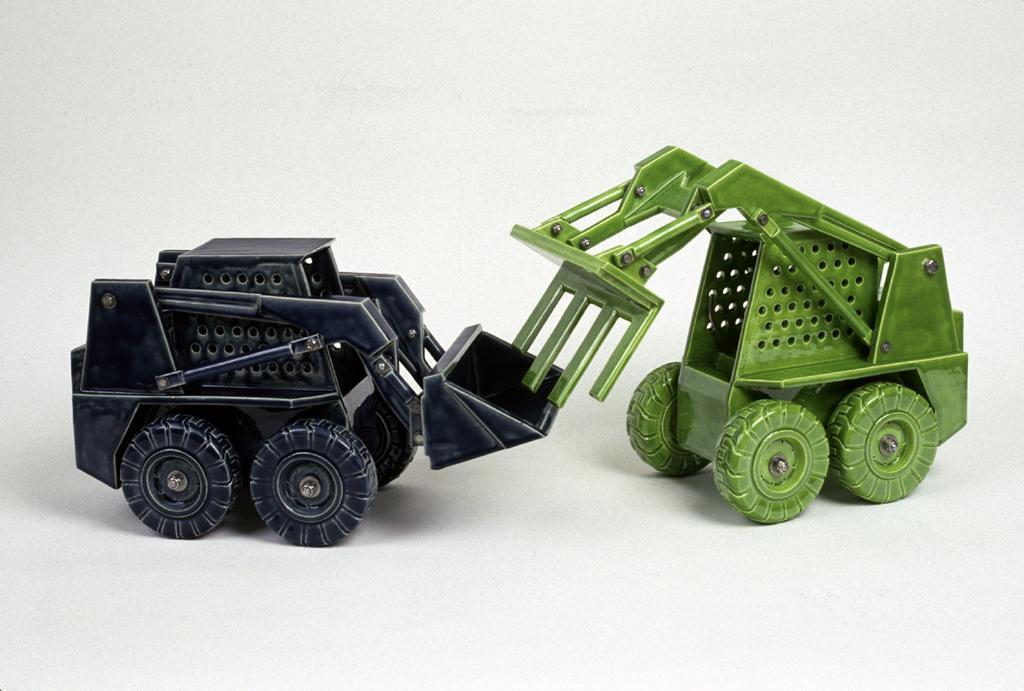Please provide a concise description of this image. We can see green and black color toy vehicles. In the background it is white. 